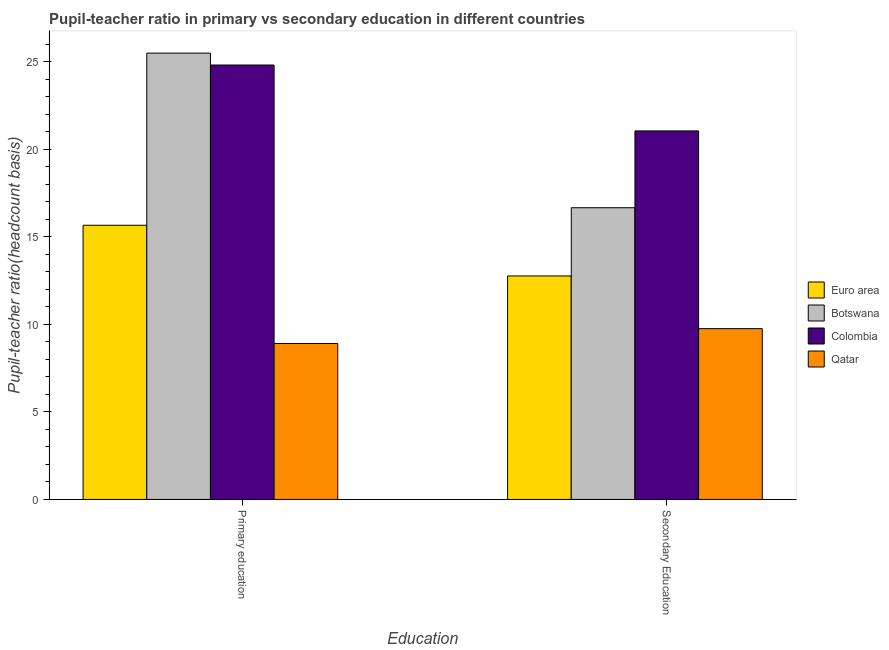How many groups of bars are there?
Provide a succinct answer. 2. Are the number of bars per tick equal to the number of legend labels?
Provide a succinct answer. Yes. How many bars are there on the 2nd tick from the left?
Make the answer very short. 4. What is the pupil teacher ratio on secondary education in Euro area?
Provide a succinct answer. 12.76. Across all countries, what is the maximum pupil-teacher ratio in primary education?
Your answer should be compact. 25.49. Across all countries, what is the minimum pupil-teacher ratio in primary education?
Make the answer very short. 8.91. In which country was the pupil teacher ratio on secondary education maximum?
Make the answer very short. Colombia. In which country was the pupil-teacher ratio in primary education minimum?
Give a very brief answer. Qatar. What is the total pupil-teacher ratio in primary education in the graph?
Give a very brief answer. 74.87. What is the difference between the pupil-teacher ratio in primary education in Colombia and that in Botswana?
Offer a terse response. -0.68. What is the difference between the pupil-teacher ratio in primary education in Colombia and the pupil teacher ratio on secondary education in Qatar?
Your answer should be very brief. 15.06. What is the average pupil-teacher ratio in primary education per country?
Offer a terse response. 18.72. What is the difference between the pupil teacher ratio on secondary education and pupil-teacher ratio in primary education in Euro area?
Your response must be concise. -2.89. What is the ratio of the pupil teacher ratio on secondary education in Euro area to that in Qatar?
Offer a terse response. 1.31. Is the pupil teacher ratio on secondary education in Euro area less than that in Qatar?
Make the answer very short. No. In how many countries, is the pupil-teacher ratio in primary education greater than the average pupil-teacher ratio in primary education taken over all countries?
Provide a succinct answer. 2. What does the 1st bar from the right in Secondary Education represents?
Your answer should be very brief. Qatar. How many bars are there?
Your answer should be compact. 8. What is the title of the graph?
Your response must be concise. Pupil-teacher ratio in primary vs secondary education in different countries. Does "Uganda" appear as one of the legend labels in the graph?
Your response must be concise. No. What is the label or title of the X-axis?
Your answer should be compact. Education. What is the label or title of the Y-axis?
Make the answer very short. Pupil-teacher ratio(headcount basis). What is the Pupil-teacher ratio(headcount basis) of Euro area in Primary education?
Your answer should be very brief. 15.66. What is the Pupil-teacher ratio(headcount basis) in Botswana in Primary education?
Your response must be concise. 25.49. What is the Pupil-teacher ratio(headcount basis) of Colombia in Primary education?
Offer a terse response. 24.81. What is the Pupil-teacher ratio(headcount basis) of Qatar in Primary education?
Ensure brevity in your answer.  8.91. What is the Pupil-teacher ratio(headcount basis) in Euro area in Secondary Education?
Your answer should be very brief. 12.76. What is the Pupil-teacher ratio(headcount basis) in Botswana in Secondary Education?
Make the answer very short. 16.66. What is the Pupil-teacher ratio(headcount basis) of Colombia in Secondary Education?
Offer a terse response. 21.05. What is the Pupil-teacher ratio(headcount basis) in Qatar in Secondary Education?
Make the answer very short. 9.76. Across all Education, what is the maximum Pupil-teacher ratio(headcount basis) of Euro area?
Keep it short and to the point. 15.66. Across all Education, what is the maximum Pupil-teacher ratio(headcount basis) of Botswana?
Ensure brevity in your answer.  25.49. Across all Education, what is the maximum Pupil-teacher ratio(headcount basis) in Colombia?
Keep it short and to the point. 24.81. Across all Education, what is the maximum Pupil-teacher ratio(headcount basis) of Qatar?
Your answer should be very brief. 9.76. Across all Education, what is the minimum Pupil-teacher ratio(headcount basis) in Euro area?
Your answer should be very brief. 12.76. Across all Education, what is the minimum Pupil-teacher ratio(headcount basis) of Botswana?
Ensure brevity in your answer.  16.66. Across all Education, what is the minimum Pupil-teacher ratio(headcount basis) in Colombia?
Your answer should be very brief. 21.05. Across all Education, what is the minimum Pupil-teacher ratio(headcount basis) in Qatar?
Your answer should be compact. 8.91. What is the total Pupil-teacher ratio(headcount basis) in Euro area in the graph?
Make the answer very short. 28.42. What is the total Pupil-teacher ratio(headcount basis) of Botswana in the graph?
Your response must be concise. 42.15. What is the total Pupil-teacher ratio(headcount basis) in Colombia in the graph?
Provide a succinct answer. 45.86. What is the total Pupil-teacher ratio(headcount basis) in Qatar in the graph?
Provide a short and direct response. 18.66. What is the difference between the Pupil-teacher ratio(headcount basis) in Euro area in Primary education and that in Secondary Education?
Keep it short and to the point. 2.89. What is the difference between the Pupil-teacher ratio(headcount basis) in Botswana in Primary education and that in Secondary Education?
Make the answer very short. 8.83. What is the difference between the Pupil-teacher ratio(headcount basis) in Colombia in Primary education and that in Secondary Education?
Provide a short and direct response. 3.76. What is the difference between the Pupil-teacher ratio(headcount basis) in Qatar in Primary education and that in Secondary Education?
Your answer should be very brief. -0.85. What is the difference between the Pupil-teacher ratio(headcount basis) of Euro area in Primary education and the Pupil-teacher ratio(headcount basis) of Botswana in Secondary Education?
Offer a very short reply. -1. What is the difference between the Pupil-teacher ratio(headcount basis) of Euro area in Primary education and the Pupil-teacher ratio(headcount basis) of Colombia in Secondary Education?
Your answer should be compact. -5.39. What is the difference between the Pupil-teacher ratio(headcount basis) in Euro area in Primary education and the Pupil-teacher ratio(headcount basis) in Qatar in Secondary Education?
Provide a short and direct response. 5.9. What is the difference between the Pupil-teacher ratio(headcount basis) in Botswana in Primary education and the Pupil-teacher ratio(headcount basis) in Colombia in Secondary Education?
Offer a terse response. 4.44. What is the difference between the Pupil-teacher ratio(headcount basis) of Botswana in Primary education and the Pupil-teacher ratio(headcount basis) of Qatar in Secondary Education?
Offer a terse response. 15.74. What is the difference between the Pupil-teacher ratio(headcount basis) in Colombia in Primary education and the Pupil-teacher ratio(headcount basis) in Qatar in Secondary Education?
Offer a very short reply. 15.06. What is the average Pupil-teacher ratio(headcount basis) in Euro area per Education?
Your answer should be compact. 14.21. What is the average Pupil-teacher ratio(headcount basis) in Botswana per Education?
Provide a succinct answer. 21.08. What is the average Pupil-teacher ratio(headcount basis) of Colombia per Education?
Your answer should be compact. 22.93. What is the average Pupil-teacher ratio(headcount basis) of Qatar per Education?
Ensure brevity in your answer.  9.33. What is the difference between the Pupil-teacher ratio(headcount basis) of Euro area and Pupil-teacher ratio(headcount basis) of Botswana in Primary education?
Give a very brief answer. -9.83. What is the difference between the Pupil-teacher ratio(headcount basis) of Euro area and Pupil-teacher ratio(headcount basis) of Colombia in Primary education?
Keep it short and to the point. -9.15. What is the difference between the Pupil-teacher ratio(headcount basis) in Euro area and Pupil-teacher ratio(headcount basis) in Qatar in Primary education?
Give a very brief answer. 6.75. What is the difference between the Pupil-teacher ratio(headcount basis) of Botswana and Pupil-teacher ratio(headcount basis) of Colombia in Primary education?
Provide a succinct answer. 0.68. What is the difference between the Pupil-teacher ratio(headcount basis) in Botswana and Pupil-teacher ratio(headcount basis) in Qatar in Primary education?
Make the answer very short. 16.58. What is the difference between the Pupil-teacher ratio(headcount basis) in Colombia and Pupil-teacher ratio(headcount basis) in Qatar in Primary education?
Offer a terse response. 15.91. What is the difference between the Pupil-teacher ratio(headcount basis) of Euro area and Pupil-teacher ratio(headcount basis) of Botswana in Secondary Education?
Keep it short and to the point. -3.9. What is the difference between the Pupil-teacher ratio(headcount basis) of Euro area and Pupil-teacher ratio(headcount basis) of Colombia in Secondary Education?
Offer a terse response. -8.28. What is the difference between the Pupil-teacher ratio(headcount basis) in Euro area and Pupil-teacher ratio(headcount basis) in Qatar in Secondary Education?
Keep it short and to the point. 3.01. What is the difference between the Pupil-teacher ratio(headcount basis) in Botswana and Pupil-teacher ratio(headcount basis) in Colombia in Secondary Education?
Offer a very short reply. -4.39. What is the difference between the Pupil-teacher ratio(headcount basis) of Botswana and Pupil-teacher ratio(headcount basis) of Qatar in Secondary Education?
Your response must be concise. 6.91. What is the difference between the Pupil-teacher ratio(headcount basis) of Colombia and Pupil-teacher ratio(headcount basis) of Qatar in Secondary Education?
Provide a short and direct response. 11.29. What is the ratio of the Pupil-teacher ratio(headcount basis) of Euro area in Primary education to that in Secondary Education?
Keep it short and to the point. 1.23. What is the ratio of the Pupil-teacher ratio(headcount basis) in Botswana in Primary education to that in Secondary Education?
Keep it short and to the point. 1.53. What is the ratio of the Pupil-teacher ratio(headcount basis) of Colombia in Primary education to that in Secondary Education?
Your response must be concise. 1.18. What is the ratio of the Pupil-teacher ratio(headcount basis) of Qatar in Primary education to that in Secondary Education?
Your answer should be compact. 0.91. What is the difference between the highest and the second highest Pupil-teacher ratio(headcount basis) in Euro area?
Provide a short and direct response. 2.89. What is the difference between the highest and the second highest Pupil-teacher ratio(headcount basis) in Botswana?
Offer a terse response. 8.83. What is the difference between the highest and the second highest Pupil-teacher ratio(headcount basis) in Colombia?
Keep it short and to the point. 3.76. What is the difference between the highest and the second highest Pupil-teacher ratio(headcount basis) of Qatar?
Make the answer very short. 0.85. What is the difference between the highest and the lowest Pupil-teacher ratio(headcount basis) of Euro area?
Keep it short and to the point. 2.89. What is the difference between the highest and the lowest Pupil-teacher ratio(headcount basis) in Botswana?
Provide a short and direct response. 8.83. What is the difference between the highest and the lowest Pupil-teacher ratio(headcount basis) in Colombia?
Provide a short and direct response. 3.76. What is the difference between the highest and the lowest Pupil-teacher ratio(headcount basis) of Qatar?
Offer a terse response. 0.85. 